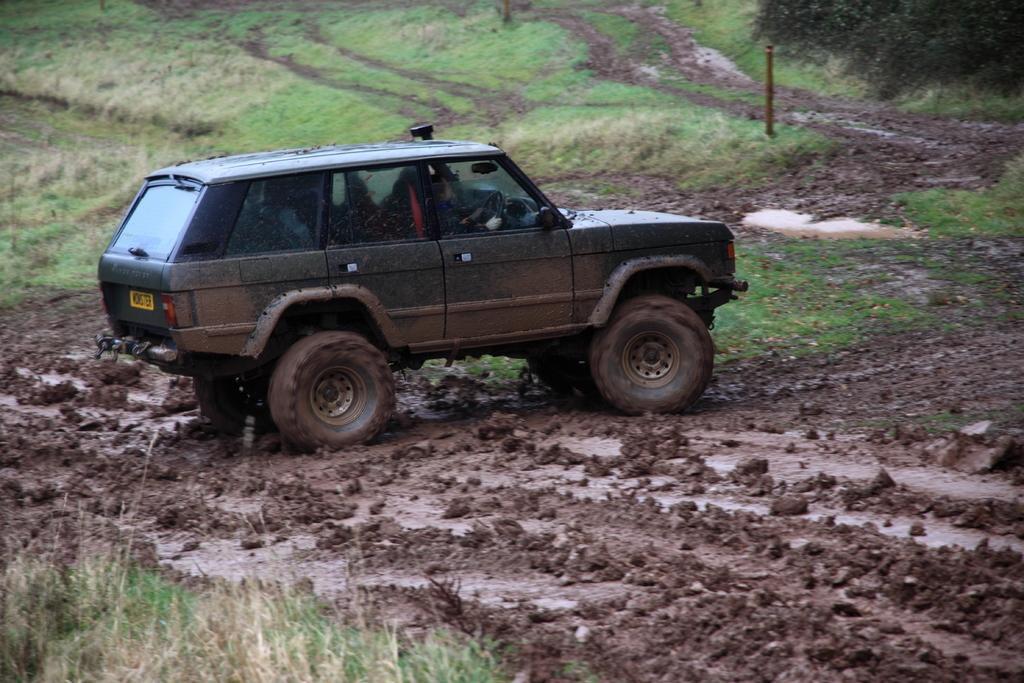Please provide a concise description of this image. In this image we can see there is a car in the mud, on the left there is grass. 